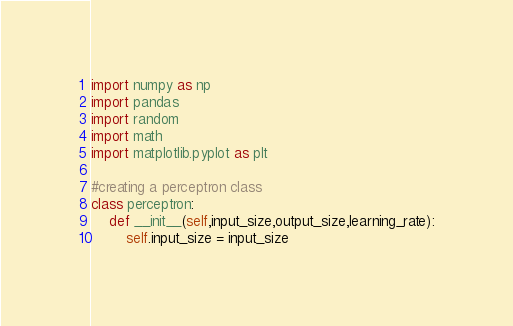<code> <loc_0><loc_0><loc_500><loc_500><_Python_>import numpy as np 
import pandas
import random
import math
import matplotlib.pyplot as plt 

#creating a perceptron class
class perceptron:
	def __init__(self,input_size,output_size,learning_rate):
		self.input_size = input_size</code> 